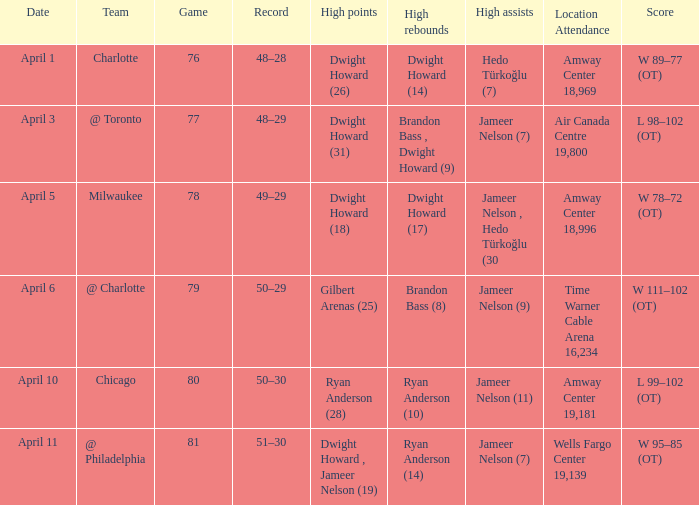Where was the game and what was the attendance on April 3?  Air Canada Centre 19,800. 